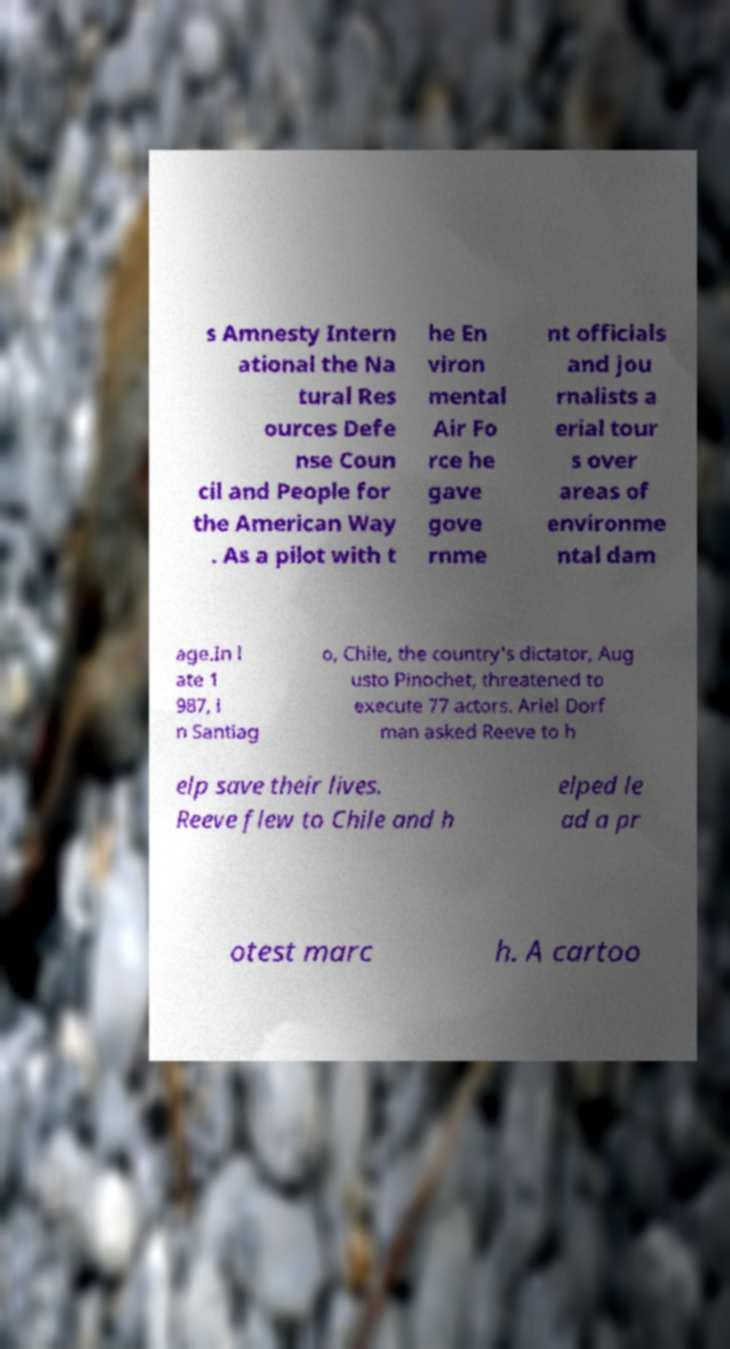There's text embedded in this image that I need extracted. Can you transcribe it verbatim? s Amnesty Intern ational the Na tural Res ources Defe nse Coun cil and People for the American Way . As a pilot with t he En viron mental Air Fo rce he gave gove rnme nt officials and jou rnalists a erial tour s over areas of environme ntal dam age.In l ate 1 987, i n Santiag o, Chile, the country's dictator, Aug usto Pinochet, threatened to execute 77 actors. Ariel Dorf man asked Reeve to h elp save their lives. Reeve flew to Chile and h elped le ad a pr otest marc h. A cartoo 